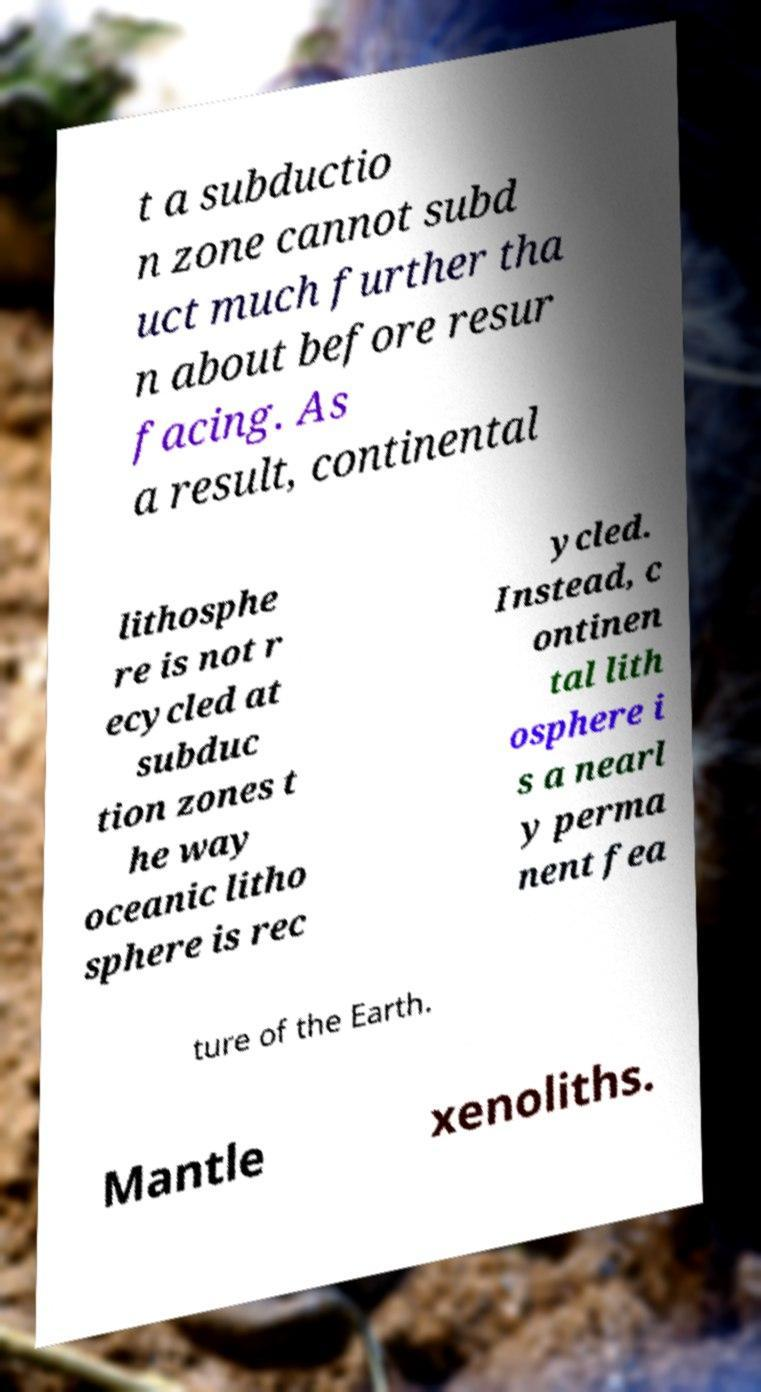What messages or text are displayed in this image? I need them in a readable, typed format. t a subductio n zone cannot subd uct much further tha n about before resur facing. As a result, continental lithosphe re is not r ecycled at subduc tion zones t he way oceanic litho sphere is rec ycled. Instead, c ontinen tal lith osphere i s a nearl y perma nent fea ture of the Earth. Mantle xenoliths. 